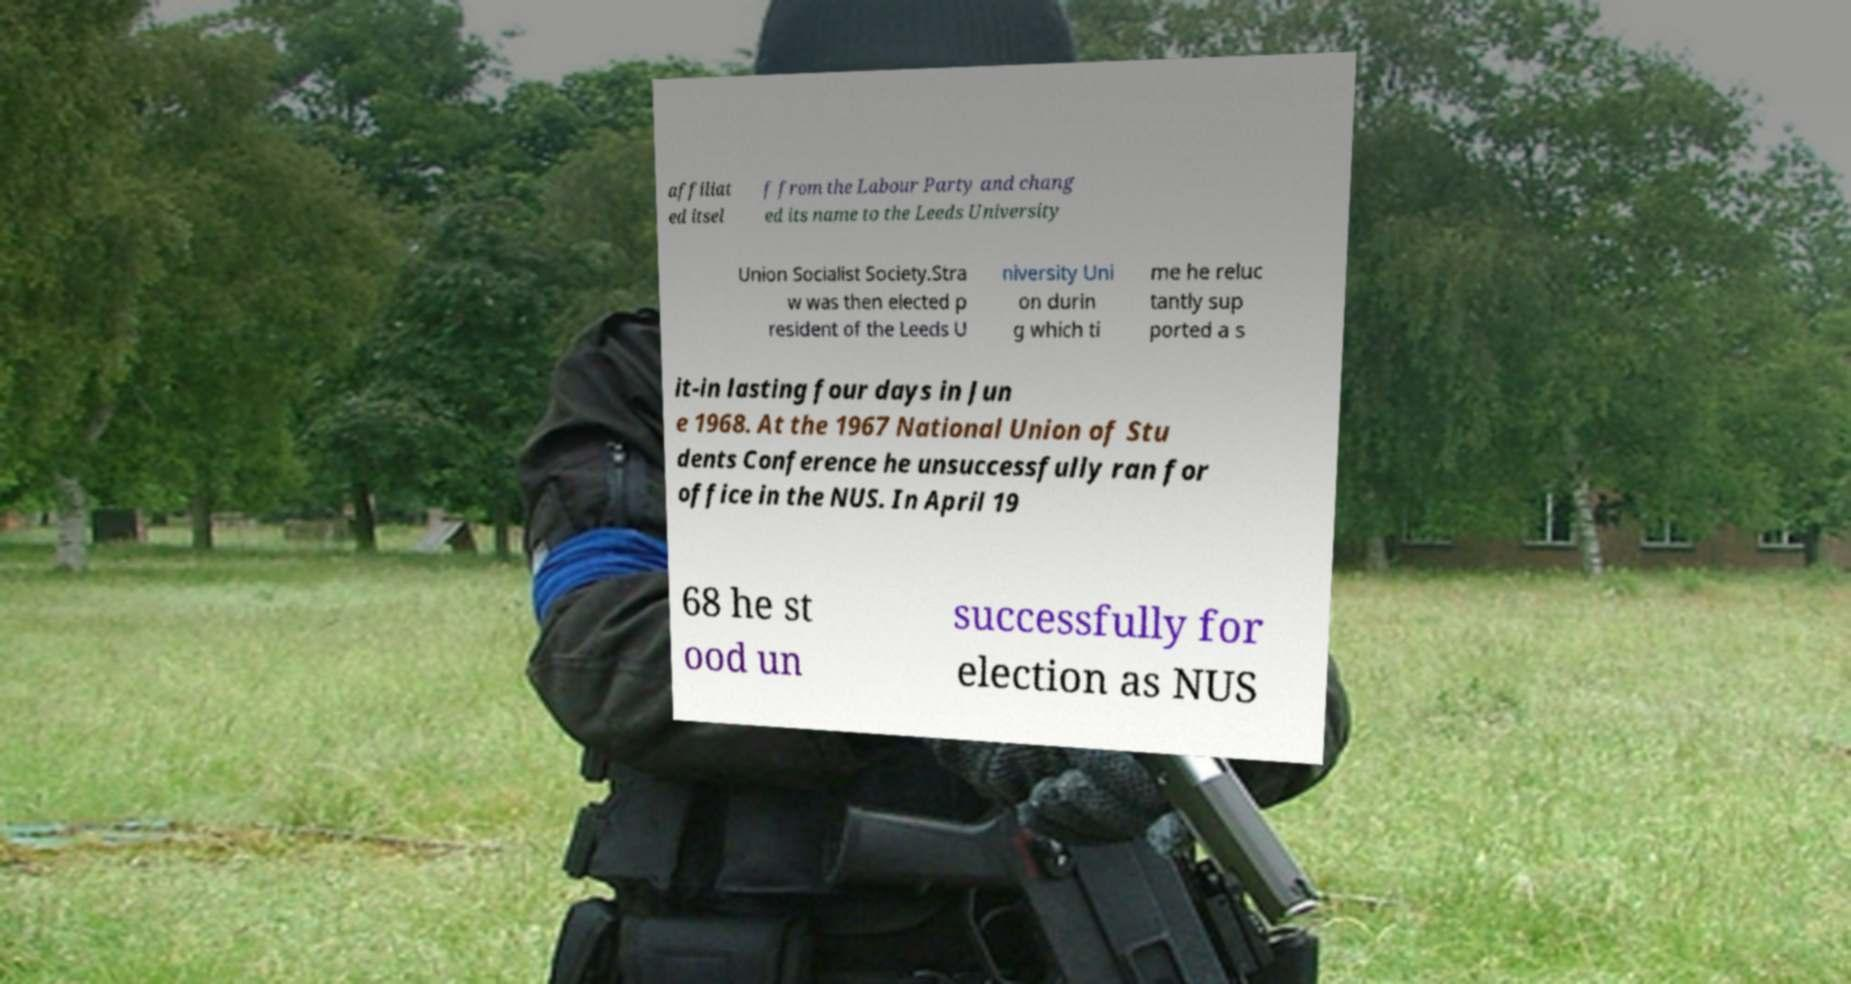Please identify and transcribe the text found in this image. affiliat ed itsel f from the Labour Party and chang ed its name to the Leeds University Union Socialist Society.Stra w was then elected p resident of the Leeds U niversity Uni on durin g which ti me he reluc tantly sup ported a s it-in lasting four days in Jun e 1968. At the 1967 National Union of Stu dents Conference he unsuccessfully ran for office in the NUS. In April 19 68 he st ood un successfully for election as NUS 